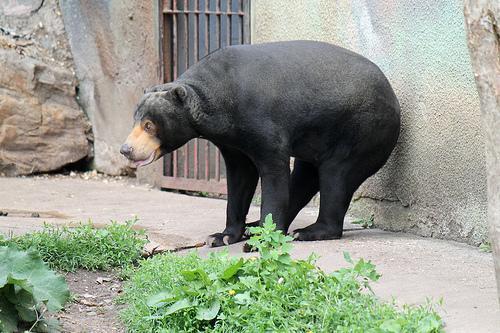How many bears are there?
Give a very brief answer. 1. 